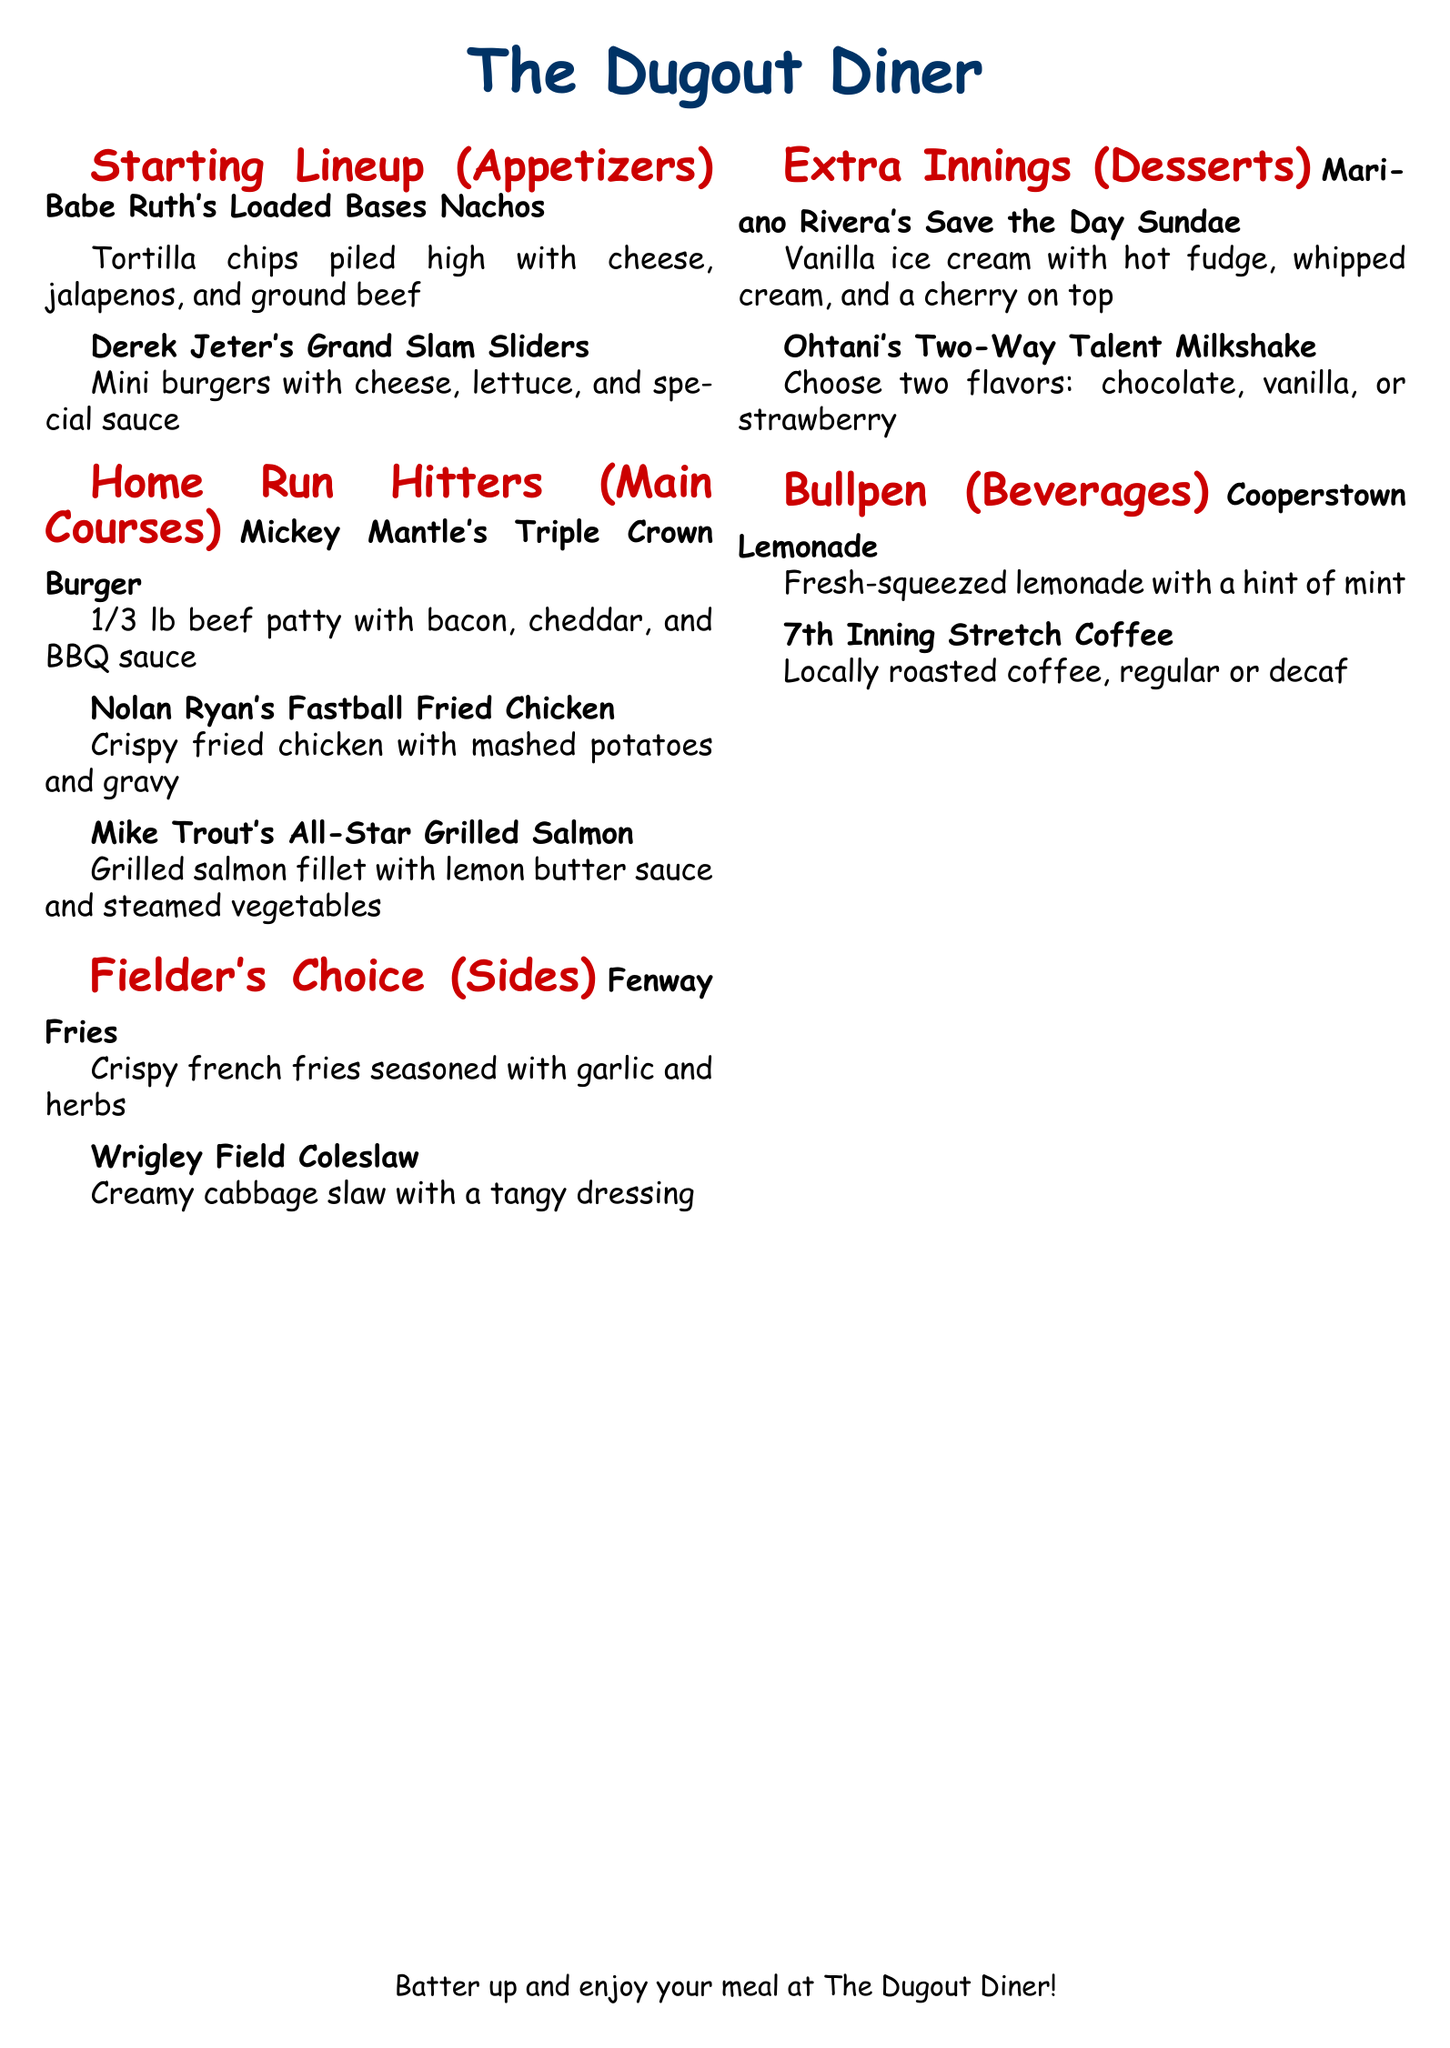What is the name of the diner? The name of the diner is prominently displayed at the top of the menu.
Answer: The Dugout Diner How many items are in the Starting Lineup section? The menu lists two items under the Starting Lineup section.
Answer: 2 What is included in Mariano Rivera's Save the Day Sundae? The description specifies the ingredients included in the dessert.
Answer: Vanilla ice cream, hot fudge, whipped cream, cherry Which beverage is represented by the name Cooperstown? The beverage name provides a connection to baseball history and is included in the menu.
Answer: Cooperstown Lemonade What type of food is Mike Trout's All-Star Grilled Salmon? The name and description indicate the main ingredient and preparation style of this dish.
Answer: Grilled salmon fillet What is the theme of the menu items? The items are inspired by famous baseball players, reflecting the theme of the diner.
Answer: Baseball-themed How many flavors can be chosen in Ohtani's Two-Way Talent Milkshake? The menu specifies the number of flavors available for this dessert item.
Answer: 2 Which dish is associated with Babe Ruth? The menu explicitly names a dish that is inspired by this legendary player.
Answer: Babe Ruth's Loaded Bases Nachos What is the side item served with Nolan Ryan's Fastball Fried Chicken? The description of the main course mentions a complementary side dish.
Answer: Mashed potatoes and gravy 